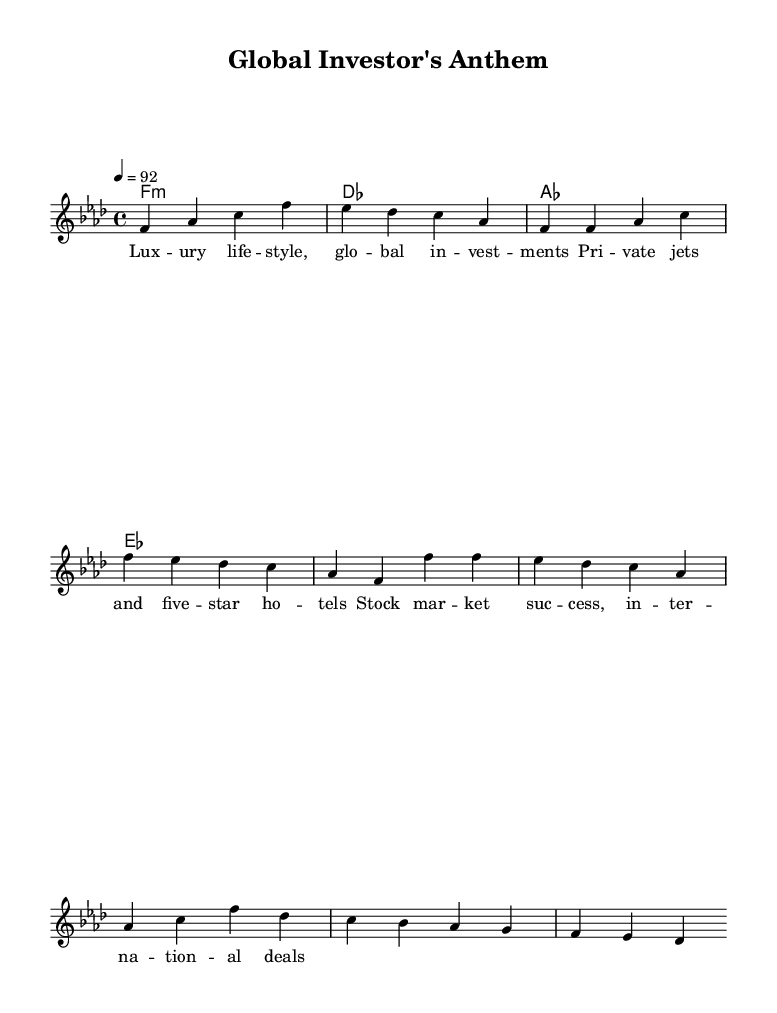What is the key signature of this music? The key signature is F minor, which contains four flats: B♭, E♭, A♭, and D♭. This information can be inferred from the global section where the key is explicitly stated.
Answer: F minor What is the time signature of this music? The time signature is 4/4, indicated in the global section before the melody starts. This means there are four beats in each measure, and each quarter note gets one beat.
Answer: 4/4 What is the tempo marking for this piece? The tempo marking is 92 beats per minute, given in the global section. This indicates how fast the piece is played, and it's marked as '4 = 92,' showing that there are 92 quarter note beats in a minute.
Answer: 92 How many measures are in the verse section? The verse section consists of four measures, identified by counting the measures in the melody section where the verse is indicated. Each group of notes separated by a bar line represents one measure.
Answer: 4 Which chords are present in the harmonies section? The chords present are F minor, D♭ major, A♭ major, and E♭ major. You can derive this information by readjusting the chord names listed under the harmonies section.
Answer: F minor, D♭, A♭, E♭ What is the main theme conveyed in the lyrics? The main theme conveyed is a luxury lifestyle and successful investments; this can be deciphered by analyzing the lyrics, which mention private jets, five-star hotels, and stock market success.
Answer: Luxury lifestyle and investments What style of music does this sheet represent? This sheet represents the rap genre, as indicated by the lyrics and the rhythmic nature of the melody. Additionally, the thematic content of the lyrics aligns with common rap subjects focusing on wealth and success.
Answer: Rap 